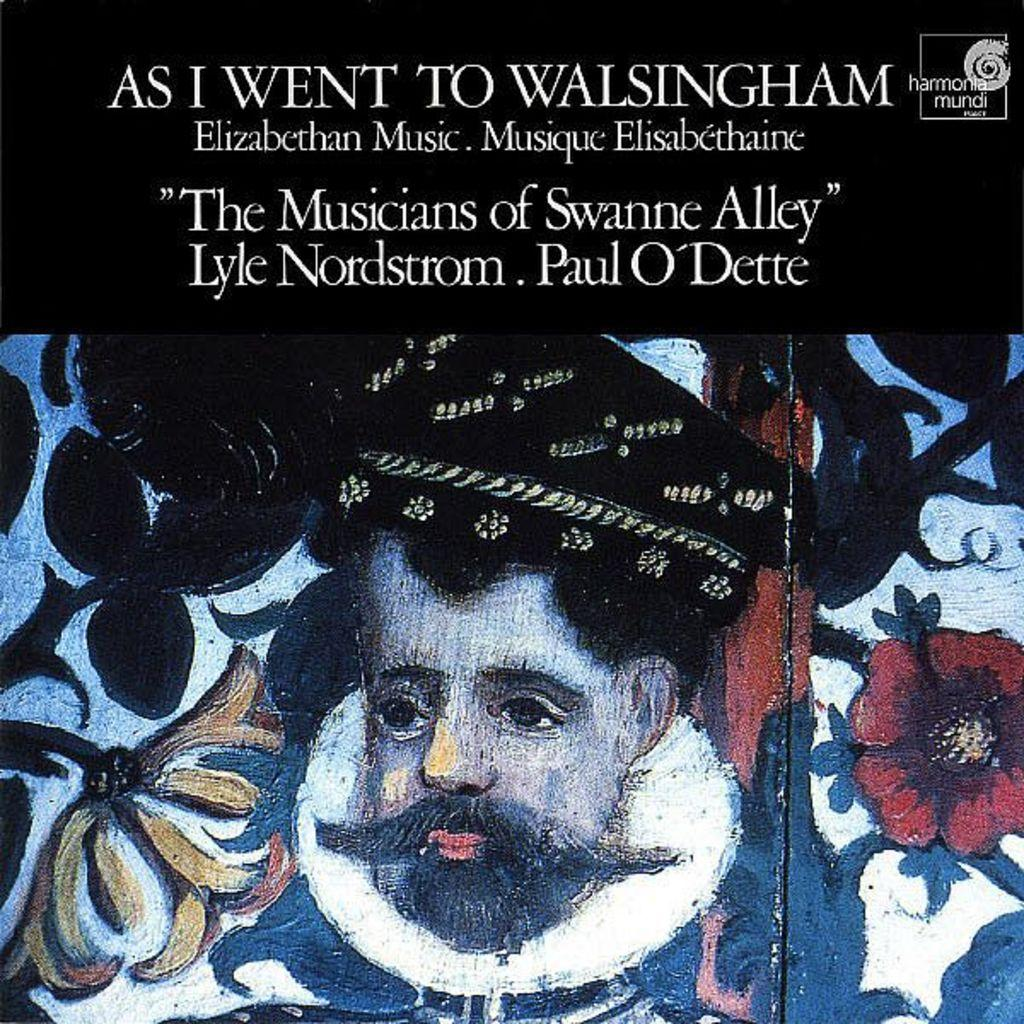What is depicted in the painting in the image? There is a painting of a person in the image. What other elements can be seen in the image besides the painting? There are flowers, text, and a logo on the top of the image. How many fowl are present in the image? There are no fowl present in the image. In which direction does the unit in the image face? There is no unit present in the image, so it is not possible to determine the direction it faces. 